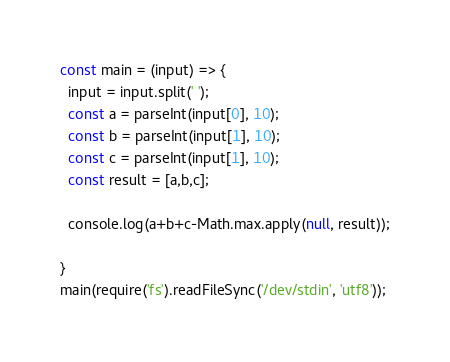<code> <loc_0><loc_0><loc_500><loc_500><_TypeScript_>const main = (input) => {
  input = input.split(' ');
  const a = parseInt(input[0], 10);
  const b = parseInt(input[1], 10);
  const c = parseInt(input[1], 10);
  const result = [a,b,c];
  
  console.log(a+b+c-Math.max.apply(null, result));
 
}
main(require('fs').readFileSync('/dev/stdin', 'utf8'));</code> 